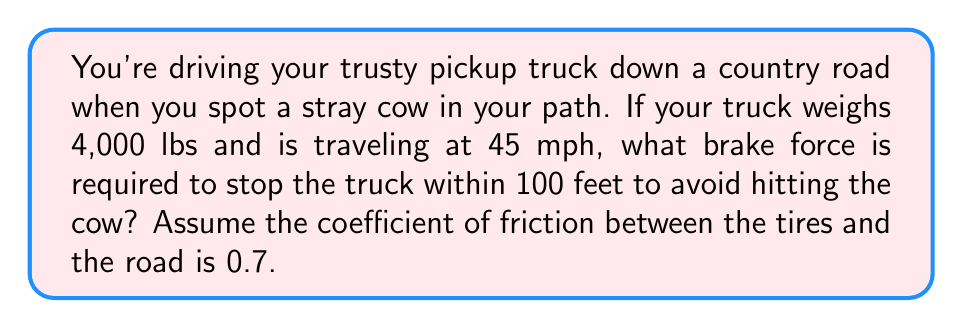Can you answer this question? Let's approach this step-by-step:

1) First, we need to convert our units:
   45 mph = 66 ft/s
   4,000 lbs = 4,000 / 32.2 = 124.22 slugs (mass)

2) We'll use the work-energy principle: the work done by the braking force equals the change in kinetic energy.

   $$W = \Delta KE$$
   $$F \cdot d = \frac{1}{2}mv^2 - \frac{1}{2}mv_f^2$$

   Where $F$ is the brake force, $d$ is the stopping distance, $m$ is the mass, $v$ is the initial velocity, and $v_f$ is the final velocity (0 in this case).

3) Substituting our values:

   $$F \cdot 100 = \frac{1}{2} \cdot 124.22 \cdot 66^2 - 0$$

4) Solving for $F$:

   $$F = \frac{124.22 \cdot 66^2}{2 \cdot 100} = 2,704.4 \text{ lbs}$$

5) However, this is the total force required. The actual brake force is limited by the friction between the tires and the road:

   $$F_{max} = \mu \cdot m \cdot g$$

   Where $\mu$ is the coefficient of friction, $m$ is the mass, and $g$ is the acceleration due to gravity (32.2 ft/s²).

6) Calculating the maximum friction force:

   $$F_{max} = 0.7 \cdot 4,000 \cdot 32.2 / 32.2 = 2,800 \text{ lbs}$$

7) Since $F_{max} > F$, the required brake force can be achieved.
Answer: The required brake force to stop the truck within 100 feet is 2,704.4 lbs. 